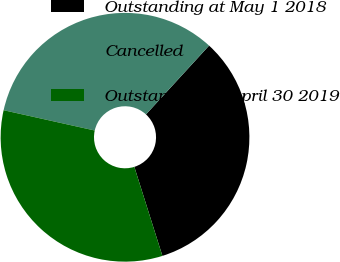Convert chart. <chart><loc_0><loc_0><loc_500><loc_500><pie_chart><fcel>Outstanding at May 1 2018<fcel>Cancelled<fcel>Outstanding at April 30 2019<nl><fcel>33.33%<fcel>33.32%<fcel>33.35%<nl></chart> 